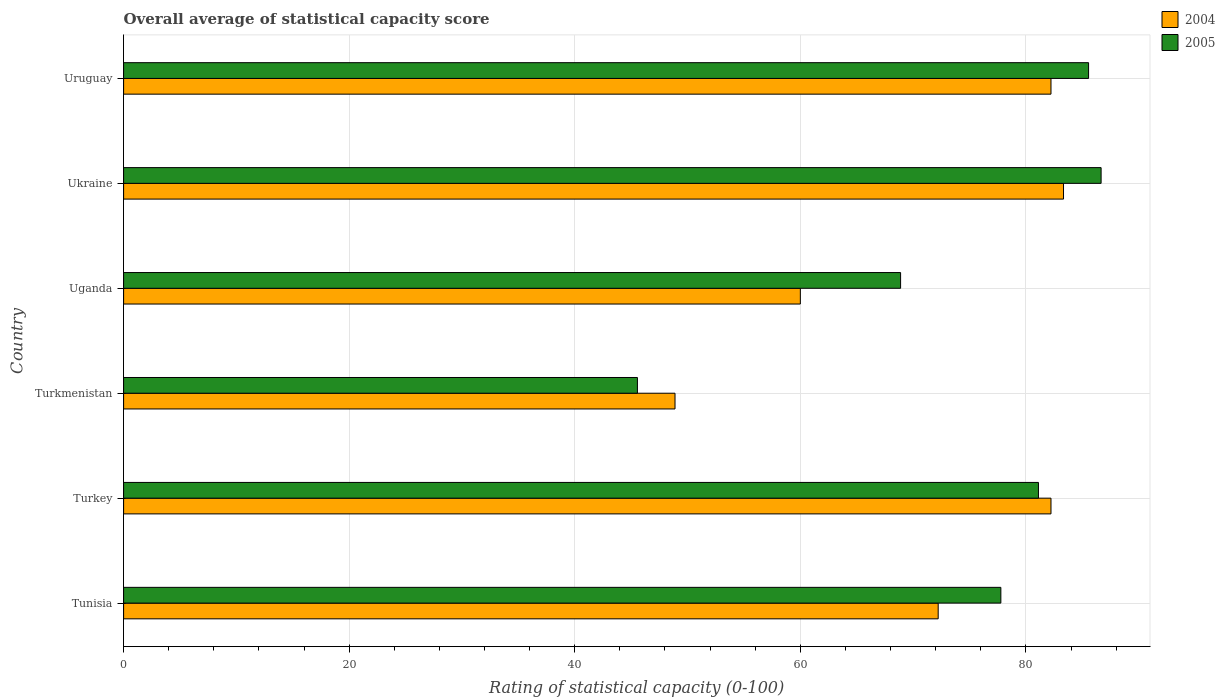Are the number of bars on each tick of the Y-axis equal?
Keep it short and to the point. Yes. How many bars are there on the 2nd tick from the bottom?
Provide a short and direct response. 2. What is the label of the 3rd group of bars from the top?
Offer a terse response. Uganda. What is the rating of statistical capacity in 2004 in Turkmenistan?
Offer a terse response. 48.89. Across all countries, what is the maximum rating of statistical capacity in 2004?
Your answer should be very brief. 83.33. Across all countries, what is the minimum rating of statistical capacity in 2005?
Give a very brief answer. 45.56. In which country was the rating of statistical capacity in 2005 maximum?
Ensure brevity in your answer.  Ukraine. In which country was the rating of statistical capacity in 2004 minimum?
Keep it short and to the point. Turkmenistan. What is the total rating of statistical capacity in 2004 in the graph?
Your response must be concise. 428.89. What is the difference between the rating of statistical capacity in 2004 in Turkmenistan and that in Uruguay?
Provide a succinct answer. -33.33. What is the difference between the rating of statistical capacity in 2004 in Uruguay and the rating of statistical capacity in 2005 in Ukraine?
Give a very brief answer. -4.44. What is the average rating of statistical capacity in 2005 per country?
Ensure brevity in your answer.  74.26. What is the difference between the rating of statistical capacity in 2005 and rating of statistical capacity in 2004 in Tunisia?
Ensure brevity in your answer.  5.56. What is the ratio of the rating of statistical capacity in 2005 in Turkey to that in Ukraine?
Your response must be concise. 0.94. Is the rating of statistical capacity in 2005 in Tunisia less than that in Uganda?
Your response must be concise. No. What is the difference between the highest and the second highest rating of statistical capacity in 2004?
Provide a short and direct response. 1.11. What is the difference between the highest and the lowest rating of statistical capacity in 2005?
Ensure brevity in your answer.  41.11. In how many countries, is the rating of statistical capacity in 2004 greater than the average rating of statistical capacity in 2004 taken over all countries?
Offer a very short reply. 4. Are all the bars in the graph horizontal?
Provide a short and direct response. Yes. Does the graph contain any zero values?
Offer a terse response. No. How many legend labels are there?
Ensure brevity in your answer.  2. What is the title of the graph?
Make the answer very short. Overall average of statistical capacity score. Does "2003" appear as one of the legend labels in the graph?
Ensure brevity in your answer.  No. What is the label or title of the X-axis?
Keep it short and to the point. Rating of statistical capacity (0-100). What is the label or title of the Y-axis?
Make the answer very short. Country. What is the Rating of statistical capacity (0-100) in 2004 in Tunisia?
Your answer should be very brief. 72.22. What is the Rating of statistical capacity (0-100) in 2005 in Tunisia?
Your answer should be compact. 77.78. What is the Rating of statistical capacity (0-100) in 2004 in Turkey?
Make the answer very short. 82.22. What is the Rating of statistical capacity (0-100) in 2005 in Turkey?
Give a very brief answer. 81.11. What is the Rating of statistical capacity (0-100) of 2004 in Turkmenistan?
Your response must be concise. 48.89. What is the Rating of statistical capacity (0-100) in 2005 in Turkmenistan?
Provide a short and direct response. 45.56. What is the Rating of statistical capacity (0-100) of 2004 in Uganda?
Make the answer very short. 60. What is the Rating of statistical capacity (0-100) in 2005 in Uganda?
Provide a succinct answer. 68.89. What is the Rating of statistical capacity (0-100) of 2004 in Ukraine?
Offer a very short reply. 83.33. What is the Rating of statistical capacity (0-100) of 2005 in Ukraine?
Offer a very short reply. 86.67. What is the Rating of statistical capacity (0-100) in 2004 in Uruguay?
Your answer should be compact. 82.22. What is the Rating of statistical capacity (0-100) in 2005 in Uruguay?
Give a very brief answer. 85.56. Across all countries, what is the maximum Rating of statistical capacity (0-100) of 2004?
Provide a short and direct response. 83.33. Across all countries, what is the maximum Rating of statistical capacity (0-100) of 2005?
Keep it short and to the point. 86.67. Across all countries, what is the minimum Rating of statistical capacity (0-100) in 2004?
Your answer should be compact. 48.89. Across all countries, what is the minimum Rating of statistical capacity (0-100) of 2005?
Give a very brief answer. 45.56. What is the total Rating of statistical capacity (0-100) of 2004 in the graph?
Provide a succinct answer. 428.89. What is the total Rating of statistical capacity (0-100) in 2005 in the graph?
Offer a terse response. 445.56. What is the difference between the Rating of statistical capacity (0-100) of 2005 in Tunisia and that in Turkey?
Ensure brevity in your answer.  -3.33. What is the difference between the Rating of statistical capacity (0-100) in 2004 in Tunisia and that in Turkmenistan?
Ensure brevity in your answer.  23.33. What is the difference between the Rating of statistical capacity (0-100) in 2005 in Tunisia and that in Turkmenistan?
Ensure brevity in your answer.  32.22. What is the difference between the Rating of statistical capacity (0-100) in 2004 in Tunisia and that in Uganda?
Offer a very short reply. 12.22. What is the difference between the Rating of statistical capacity (0-100) of 2005 in Tunisia and that in Uganda?
Your answer should be compact. 8.89. What is the difference between the Rating of statistical capacity (0-100) in 2004 in Tunisia and that in Ukraine?
Keep it short and to the point. -11.11. What is the difference between the Rating of statistical capacity (0-100) of 2005 in Tunisia and that in Ukraine?
Keep it short and to the point. -8.89. What is the difference between the Rating of statistical capacity (0-100) of 2004 in Tunisia and that in Uruguay?
Offer a terse response. -10. What is the difference between the Rating of statistical capacity (0-100) of 2005 in Tunisia and that in Uruguay?
Provide a short and direct response. -7.78. What is the difference between the Rating of statistical capacity (0-100) in 2004 in Turkey and that in Turkmenistan?
Offer a terse response. 33.33. What is the difference between the Rating of statistical capacity (0-100) in 2005 in Turkey and that in Turkmenistan?
Give a very brief answer. 35.56. What is the difference between the Rating of statistical capacity (0-100) in 2004 in Turkey and that in Uganda?
Offer a terse response. 22.22. What is the difference between the Rating of statistical capacity (0-100) of 2005 in Turkey and that in Uganda?
Offer a terse response. 12.22. What is the difference between the Rating of statistical capacity (0-100) in 2004 in Turkey and that in Ukraine?
Ensure brevity in your answer.  -1.11. What is the difference between the Rating of statistical capacity (0-100) of 2005 in Turkey and that in Ukraine?
Offer a terse response. -5.56. What is the difference between the Rating of statistical capacity (0-100) of 2005 in Turkey and that in Uruguay?
Keep it short and to the point. -4.44. What is the difference between the Rating of statistical capacity (0-100) of 2004 in Turkmenistan and that in Uganda?
Make the answer very short. -11.11. What is the difference between the Rating of statistical capacity (0-100) in 2005 in Turkmenistan and that in Uganda?
Provide a short and direct response. -23.33. What is the difference between the Rating of statistical capacity (0-100) of 2004 in Turkmenistan and that in Ukraine?
Ensure brevity in your answer.  -34.44. What is the difference between the Rating of statistical capacity (0-100) in 2005 in Turkmenistan and that in Ukraine?
Provide a short and direct response. -41.11. What is the difference between the Rating of statistical capacity (0-100) of 2004 in Turkmenistan and that in Uruguay?
Offer a terse response. -33.33. What is the difference between the Rating of statistical capacity (0-100) in 2005 in Turkmenistan and that in Uruguay?
Offer a very short reply. -40. What is the difference between the Rating of statistical capacity (0-100) of 2004 in Uganda and that in Ukraine?
Offer a very short reply. -23.33. What is the difference between the Rating of statistical capacity (0-100) in 2005 in Uganda and that in Ukraine?
Ensure brevity in your answer.  -17.78. What is the difference between the Rating of statistical capacity (0-100) in 2004 in Uganda and that in Uruguay?
Your response must be concise. -22.22. What is the difference between the Rating of statistical capacity (0-100) in 2005 in Uganda and that in Uruguay?
Provide a short and direct response. -16.67. What is the difference between the Rating of statistical capacity (0-100) in 2004 in Tunisia and the Rating of statistical capacity (0-100) in 2005 in Turkey?
Your answer should be compact. -8.89. What is the difference between the Rating of statistical capacity (0-100) in 2004 in Tunisia and the Rating of statistical capacity (0-100) in 2005 in Turkmenistan?
Ensure brevity in your answer.  26.67. What is the difference between the Rating of statistical capacity (0-100) in 2004 in Tunisia and the Rating of statistical capacity (0-100) in 2005 in Ukraine?
Give a very brief answer. -14.44. What is the difference between the Rating of statistical capacity (0-100) of 2004 in Tunisia and the Rating of statistical capacity (0-100) of 2005 in Uruguay?
Make the answer very short. -13.33. What is the difference between the Rating of statistical capacity (0-100) in 2004 in Turkey and the Rating of statistical capacity (0-100) in 2005 in Turkmenistan?
Give a very brief answer. 36.67. What is the difference between the Rating of statistical capacity (0-100) in 2004 in Turkey and the Rating of statistical capacity (0-100) in 2005 in Uganda?
Your response must be concise. 13.33. What is the difference between the Rating of statistical capacity (0-100) of 2004 in Turkey and the Rating of statistical capacity (0-100) of 2005 in Ukraine?
Your response must be concise. -4.44. What is the difference between the Rating of statistical capacity (0-100) in 2004 in Turkmenistan and the Rating of statistical capacity (0-100) in 2005 in Uganda?
Make the answer very short. -20. What is the difference between the Rating of statistical capacity (0-100) of 2004 in Turkmenistan and the Rating of statistical capacity (0-100) of 2005 in Ukraine?
Provide a succinct answer. -37.78. What is the difference between the Rating of statistical capacity (0-100) of 2004 in Turkmenistan and the Rating of statistical capacity (0-100) of 2005 in Uruguay?
Your answer should be compact. -36.67. What is the difference between the Rating of statistical capacity (0-100) in 2004 in Uganda and the Rating of statistical capacity (0-100) in 2005 in Ukraine?
Your answer should be compact. -26.67. What is the difference between the Rating of statistical capacity (0-100) of 2004 in Uganda and the Rating of statistical capacity (0-100) of 2005 in Uruguay?
Offer a very short reply. -25.56. What is the difference between the Rating of statistical capacity (0-100) in 2004 in Ukraine and the Rating of statistical capacity (0-100) in 2005 in Uruguay?
Your response must be concise. -2.22. What is the average Rating of statistical capacity (0-100) in 2004 per country?
Your answer should be very brief. 71.48. What is the average Rating of statistical capacity (0-100) of 2005 per country?
Your answer should be compact. 74.26. What is the difference between the Rating of statistical capacity (0-100) of 2004 and Rating of statistical capacity (0-100) of 2005 in Tunisia?
Offer a terse response. -5.56. What is the difference between the Rating of statistical capacity (0-100) in 2004 and Rating of statistical capacity (0-100) in 2005 in Turkey?
Keep it short and to the point. 1.11. What is the difference between the Rating of statistical capacity (0-100) of 2004 and Rating of statistical capacity (0-100) of 2005 in Turkmenistan?
Your response must be concise. 3.33. What is the difference between the Rating of statistical capacity (0-100) in 2004 and Rating of statistical capacity (0-100) in 2005 in Uganda?
Offer a very short reply. -8.89. What is the difference between the Rating of statistical capacity (0-100) in 2004 and Rating of statistical capacity (0-100) in 2005 in Uruguay?
Your answer should be compact. -3.33. What is the ratio of the Rating of statistical capacity (0-100) in 2004 in Tunisia to that in Turkey?
Your response must be concise. 0.88. What is the ratio of the Rating of statistical capacity (0-100) in 2005 in Tunisia to that in Turkey?
Your response must be concise. 0.96. What is the ratio of the Rating of statistical capacity (0-100) in 2004 in Tunisia to that in Turkmenistan?
Offer a very short reply. 1.48. What is the ratio of the Rating of statistical capacity (0-100) in 2005 in Tunisia to that in Turkmenistan?
Keep it short and to the point. 1.71. What is the ratio of the Rating of statistical capacity (0-100) in 2004 in Tunisia to that in Uganda?
Your answer should be very brief. 1.2. What is the ratio of the Rating of statistical capacity (0-100) in 2005 in Tunisia to that in Uganda?
Ensure brevity in your answer.  1.13. What is the ratio of the Rating of statistical capacity (0-100) in 2004 in Tunisia to that in Ukraine?
Provide a short and direct response. 0.87. What is the ratio of the Rating of statistical capacity (0-100) in 2005 in Tunisia to that in Ukraine?
Make the answer very short. 0.9. What is the ratio of the Rating of statistical capacity (0-100) in 2004 in Tunisia to that in Uruguay?
Your answer should be compact. 0.88. What is the ratio of the Rating of statistical capacity (0-100) of 2004 in Turkey to that in Turkmenistan?
Provide a short and direct response. 1.68. What is the ratio of the Rating of statistical capacity (0-100) of 2005 in Turkey to that in Turkmenistan?
Your answer should be compact. 1.78. What is the ratio of the Rating of statistical capacity (0-100) in 2004 in Turkey to that in Uganda?
Keep it short and to the point. 1.37. What is the ratio of the Rating of statistical capacity (0-100) of 2005 in Turkey to that in Uganda?
Offer a terse response. 1.18. What is the ratio of the Rating of statistical capacity (0-100) in 2004 in Turkey to that in Ukraine?
Provide a succinct answer. 0.99. What is the ratio of the Rating of statistical capacity (0-100) of 2005 in Turkey to that in Ukraine?
Provide a short and direct response. 0.94. What is the ratio of the Rating of statistical capacity (0-100) in 2005 in Turkey to that in Uruguay?
Ensure brevity in your answer.  0.95. What is the ratio of the Rating of statistical capacity (0-100) in 2004 in Turkmenistan to that in Uganda?
Your answer should be very brief. 0.81. What is the ratio of the Rating of statistical capacity (0-100) of 2005 in Turkmenistan to that in Uganda?
Your answer should be very brief. 0.66. What is the ratio of the Rating of statistical capacity (0-100) of 2004 in Turkmenistan to that in Ukraine?
Provide a succinct answer. 0.59. What is the ratio of the Rating of statistical capacity (0-100) of 2005 in Turkmenistan to that in Ukraine?
Ensure brevity in your answer.  0.53. What is the ratio of the Rating of statistical capacity (0-100) in 2004 in Turkmenistan to that in Uruguay?
Offer a terse response. 0.59. What is the ratio of the Rating of statistical capacity (0-100) of 2005 in Turkmenistan to that in Uruguay?
Ensure brevity in your answer.  0.53. What is the ratio of the Rating of statistical capacity (0-100) in 2004 in Uganda to that in Ukraine?
Provide a short and direct response. 0.72. What is the ratio of the Rating of statistical capacity (0-100) in 2005 in Uganda to that in Ukraine?
Offer a terse response. 0.79. What is the ratio of the Rating of statistical capacity (0-100) of 2004 in Uganda to that in Uruguay?
Make the answer very short. 0.73. What is the ratio of the Rating of statistical capacity (0-100) in 2005 in Uganda to that in Uruguay?
Give a very brief answer. 0.81. What is the ratio of the Rating of statistical capacity (0-100) in 2004 in Ukraine to that in Uruguay?
Make the answer very short. 1.01. What is the ratio of the Rating of statistical capacity (0-100) of 2005 in Ukraine to that in Uruguay?
Ensure brevity in your answer.  1.01. What is the difference between the highest and the second highest Rating of statistical capacity (0-100) in 2004?
Offer a terse response. 1.11. What is the difference between the highest and the lowest Rating of statistical capacity (0-100) of 2004?
Your answer should be compact. 34.44. What is the difference between the highest and the lowest Rating of statistical capacity (0-100) in 2005?
Give a very brief answer. 41.11. 